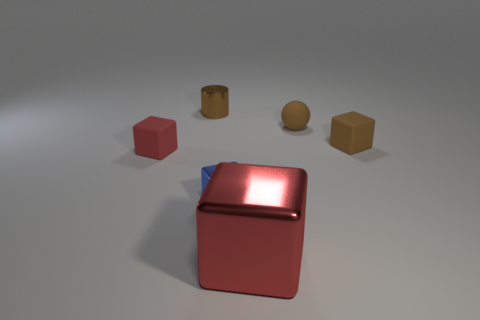Subtract all gray cylinders. Subtract all cyan blocks. How many cylinders are left? 1 Add 3 tiny blue matte blocks. How many objects exist? 9 Subtract all cubes. How many objects are left? 2 Add 2 objects. How many objects are left? 8 Add 1 small matte blocks. How many small matte blocks exist? 3 Subtract 0 green cylinders. How many objects are left? 6 Subtract all tiny shiny cylinders. Subtract all big blue things. How many objects are left? 5 